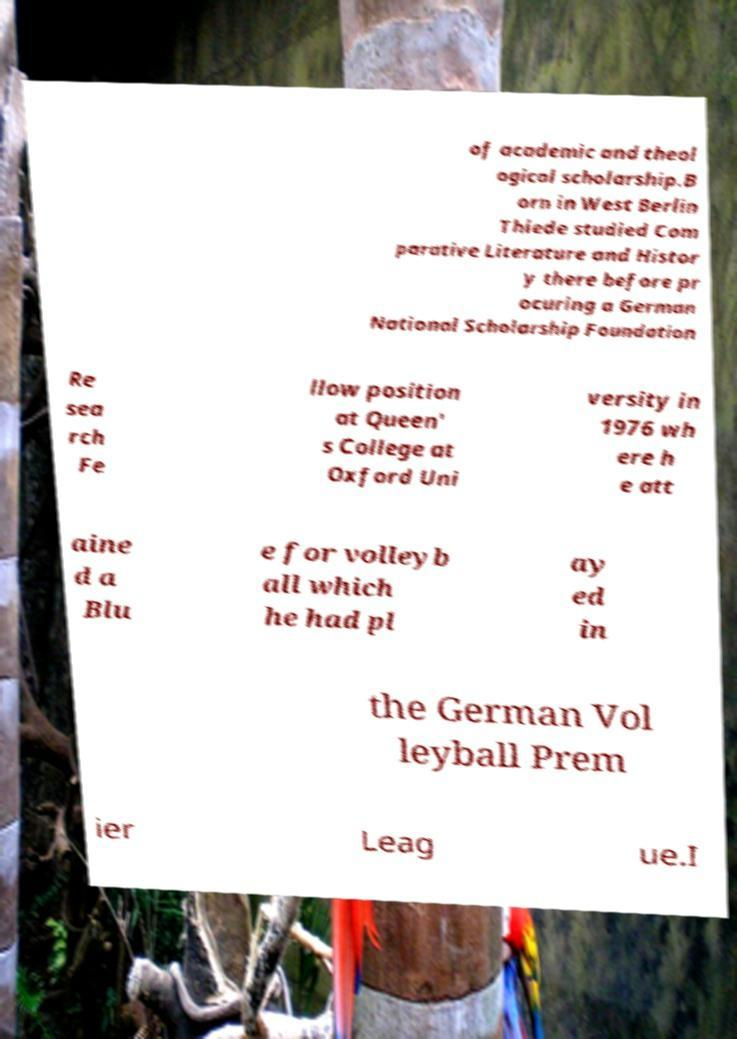There's text embedded in this image that I need extracted. Can you transcribe it verbatim? of academic and theol ogical scholarship.B orn in West Berlin Thiede studied Com parative Literature and Histor y there before pr ocuring a German National Scholarship Foundation Re sea rch Fe llow position at Queen' s College at Oxford Uni versity in 1976 wh ere h e att aine d a Blu e for volleyb all which he had pl ay ed in the German Vol leyball Prem ier Leag ue.I 